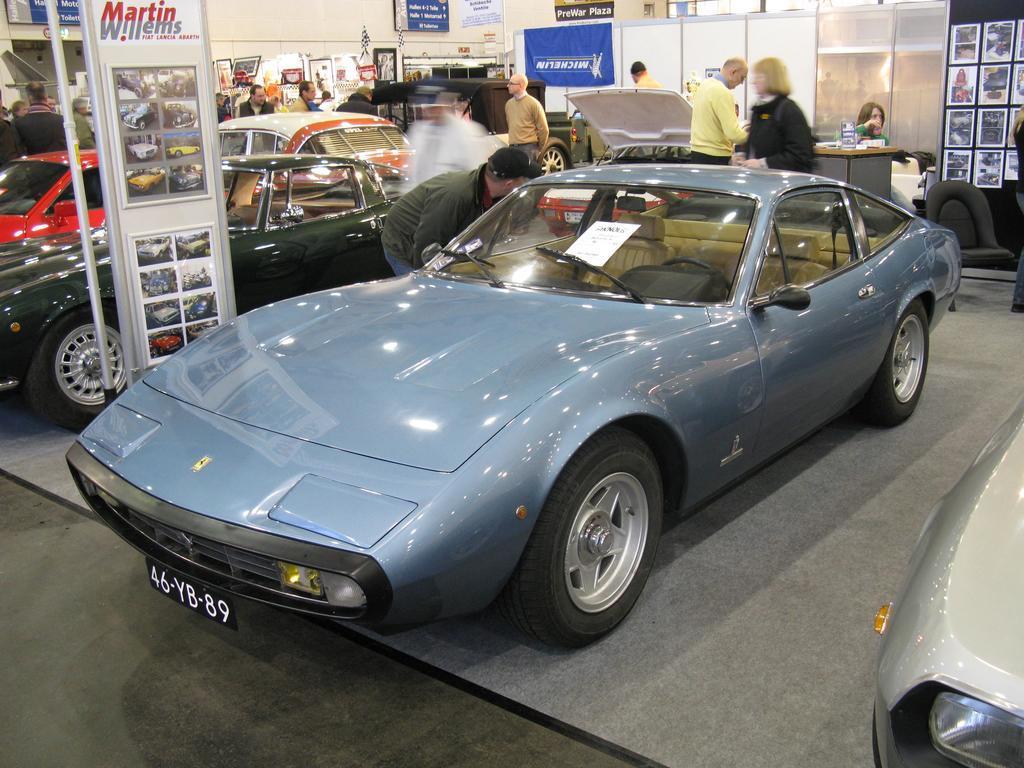Please provide a concise description of this image. In this picture there is a man who is wearing cap, green, jacket and jeans. He is standing near to the blue car and black car. On the left we can see a woman who is sitting near to the desk and holding some books. In the background we can see posts on the wall. Here we can see the plastic partition near to the car. 